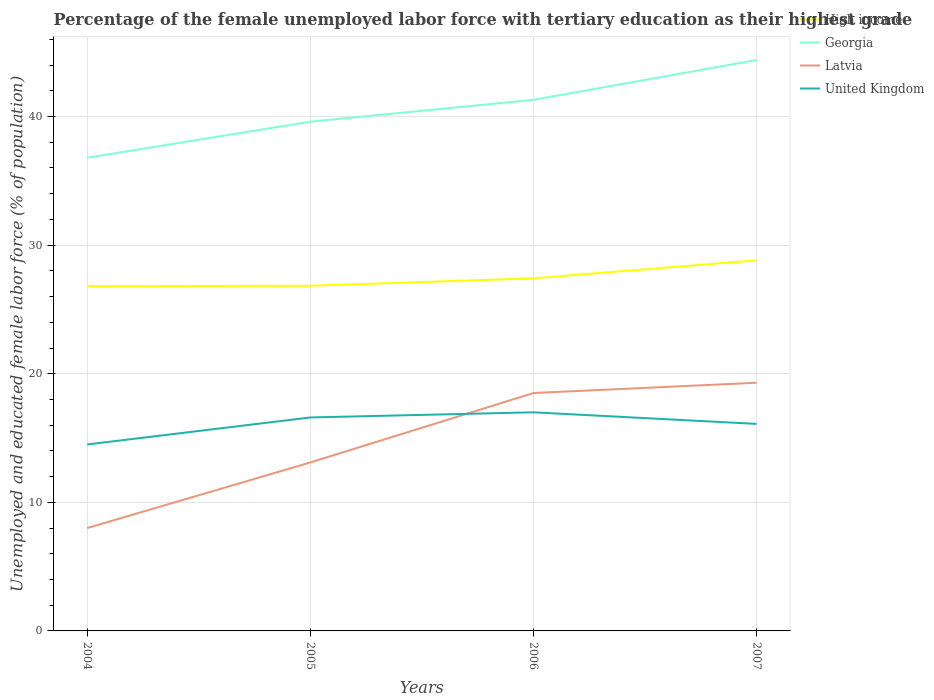Is the number of lines equal to the number of legend labels?
Provide a short and direct response. Yes. Across all years, what is the maximum percentage of the unemployed female labor force with tertiary education in High income?
Make the answer very short. 26.81. What is the difference between the highest and the second highest percentage of the unemployed female labor force with tertiary education in Georgia?
Make the answer very short. 7.6. How many lines are there?
Ensure brevity in your answer.  4. How many years are there in the graph?
Provide a succinct answer. 4. Are the values on the major ticks of Y-axis written in scientific E-notation?
Provide a succinct answer. No. Where does the legend appear in the graph?
Your answer should be compact. Top right. What is the title of the graph?
Offer a terse response. Percentage of the female unemployed labor force with tertiary education as their highest grade. Does "Virgin Islands" appear as one of the legend labels in the graph?
Make the answer very short. No. What is the label or title of the Y-axis?
Your answer should be very brief. Unemployed and educated female labor force (% of population). What is the Unemployed and educated female labor force (% of population) of High income in 2004?
Make the answer very short. 26.81. What is the Unemployed and educated female labor force (% of population) of Georgia in 2004?
Provide a succinct answer. 36.8. What is the Unemployed and educated female labor force (% of population) of United Kingdom in 2004?
Provide a succinct answer. 14.5. What is the Unemployed and educated female labor force (% of population) in High income in 2005?
Your answer should be very brief. 26.84. What is the Unemployed and educated female labor force (% of population) of Georgia in 2005?
Provide a short and direct response. 39.6. What is the Unemployed and educated female labor force (% of population) of Latvia in 2005?
Keep it short and to the point. 13.1. What is the Unemployed and educated female labor force (% of population) in United Kingdom in 2005?
Your answer should be compact. 16.6. What is the Unemployed and educated female labor force (% of population) in High income in 2006?
Offer a terse response. 27.42. What is the Unemployed and educated female labor force (% of population) of Georgia in 2006?
Keep it short and to the point. 41.3. What is the Unemployed and educated female labor force (% of population) of Latvia in 2006?
Ensure brevity in your answer.  18.5. What is the Unemployed and educated female labor force (% of population) in United Kingdom in 2006?
Ensure brevity in your answer.  17. What is the Unemployed and educated female labor force (% of population) in High income in 2007?
Provide a succinct answer. 28.82. What is the Unemployed and educated female labor force (% of population) of Georgia in 2007?
Provide a short and direct response. 44.4. What is the Unemployed and educated female labor force (% of population) in Latvia in 2007?
Your answer should be compact. 19.3. What is the Unemployed and educated female labor force (% of population) in United Kingdom in 2007?
Offer a very short reply. 16.1. Across all years, what is the maximum Unemployed and educated female labor force (% of population) in High income?
Provide a succinct answer. 28.82. Across all years, what is the maximum Unemployed and educated female labor force (% of population) in Georgia?
Make the answer very short. 44.4. Across all years, what is the maximum Unemployed and educated female labor force (% of population) of Latvia?
Ensure brevity in your answer.  19.3. Across all years, what is the maximum Unemployed and educated female labor force (% of population) of United Kingdom?
Ensure brevity in your answer.  17. Across all years, what is the minimum Unemployed and educated female labor force (% of population) in High income?
Offer a terse response. 26.81. Across all years, what is the minimum Unemployed and educated female labor force (% of population) of Georgia?
Provide a short and direct response. 36.8. Across all years, what is the minimum Unemployed and educated female labor force (% of population) in Latvia?
Keep it short and to the point. 8. What is the total Unemployed and educated female labor force (% of population) of High income in the graph?
Your response must be concise. 109.89. What is the total Unemployed and educated female labor force (% of population) in Georgia in the graph?
Ensure brevity in your answer.  162.1. What is the total Unemployed and educated female labor force (% of population) in Latvia in the graph?
Provide a succinct answer. 58.9. What is the total Unemployed and educated female labor force (% of population) in United Kingdom in the graph?
Ensure brevity in your answer.  64.2. What is the difference between the Unemployed and educated female labor force (% of population) in High income in 2004 and that in 2005?
Offer a very short reply. -0.03. What is the difference between the Unemployed and educated female labor force (% of population) of Georgia in 2004 and that in 2005?
Provide a succinct answer. -2.8. What is the difference between the Unemployed and educated female labor force (% of population) in Latvia in 2004 and that in 2005?
Your answer should be compact. -5.1. What is the difference between the Unemployed and educated female labor force (% of population) of United Kingdom in 2004 and that in 2005?
Make the answer very short. -2.1. What is the difference between the Unemployed and educated female labor force (% of population) of High income in 2004 and that in 2006?
Offer a terse response. -0.61. What is the difference between the Unemployed and educated female labor force (% of population) in High income in 2004 and that in 2007?
Ensure brevity in your answer.  -2.01. What is the difference between the Unemployed and educated female labor force (% of population) of High income in 2005 and that in 2006?
Make the answer very short. -0.58. What is the difference between the Unemployed and educated female labor force (% of population) of Georgia in 2005 and that in 2006?
Your response must be concise. -1.7. What is the difference between the Unemployed and educated female labor force (% of population) in Latvia in 2005 and that in 2006?
Your response must be concise. -5.4. What is the difference between the Unemployed and educated female labor force (% of population) in High income in 2005 and that in 2007?
Offer a terse response. -1.98. What is the difference between the Unemployed and educated female labor force (% of population) of Georgia in 2005 and that in 2007?
Your answer should be very brief. -4.8. What is the difference between the Unemployed and educated female labor force (% of population) in Latvia in 2005 and that in 2007?
Provide a short and direct response. -6.2. What is the difference between the Unemployed and educated female labor force (% of population) of United Kingdom in 2005 and that in 2007?
Provide a short and direct response. 0.5. What is the difference between the Unemployed and educated female labor force (% of population) of High income in 2006 and that in 2007?
Offer a terse response. -1.4. What is the difference between the Unemployed and educated female labor force (% of population) of Georgia in 2006 and that in 2007?
Offer a terse response. -3.1. What is the difference between the Unemployed and educated female labor force (% of population) of Latvia in 2006 and that in 2007?
Make the answer very short. -0.8. What is the difference between the Unemployed and educated female labor force (% of population) in United Kingdom in 2006 and that in 2007?
Provide a succinct answer. 0.9. What is the difference between the Unemployed and educated female labor force (% of population) in High income in 2004 and the Unemployed and educated female labor force (% of population) in Georgia in 2005?
Provide a short and direct response. -12.79. What is the difference between the Unemployed and educated female labor force (% of population) in High income in 2004 and the Unemployed and educated female labor force (% of population) in Latvia in 2005?
Ensure brevity in your answer.  13.71. What is the difference between the Unemployed and educated female labor force (% of population) in High income in 2004 and the Unemployed and educated female labor force (% of population) in United Kingdom in 2005?
Your response must be concise. 10.21. What is the difference between the Unemployed and educated female labor force (% of population) of Georgia in 2004 and the Unemployed and educated female labor force (% of population) of Latvia in 2005?
Provide a succinct answer. 23.7. What is the difference between the Unemployed and educated female labor force (% of population) of Georgia in 2004 and the Unemployed and educated female labor force (% of population) of United Kingdom in 2005?
Ensure brevity in your answer.  20.2. What is the difference between the Unemployed and educated female labor force (% of population) of Latvia in 2004 and the Unemployed and educated female labor force (% of population) of United Kingdom in 2005?
Offer a terse response. -8.6. What is the difference between the Unemployed and educated female labor force (% of population) of High income in 2004 and the Unemployed and educated female labor force (% of population) of Georgia in 2006?
Your answer should be compact. -14.49. What is the difference between the Unemployed and educated female labor force (% of population) of High income in 2004 and the Unemployed and educated female labor force (% of population) of Latvia in 2006?
Offer a terse response. 8.31. What is the difference between the Unemployed and educated female labor force (% of population) in High income in 2004 and the Unemployed and educated female labor force (% of population) in United Kingdom in 2006?
Your answer should be very brief. 9.81. What is the difference between the Unemployed and educated female labor force (% of population) of Georgia in 2004 and the Unemployed and educated female labor force (% of population) of Latvia in 2006?
Provide a short and direct response. 18.3. What is the difference between the Unemployed and educated female labor force (% of population) in Georgia in 2004 and the Unemployed and educated female labor force (% of population) in United Kingdom in 2006?
Provide a short and direct response. 19.8. What is the difference between the Unemployed and educated female labor force (% of population) of Latvia in 2004 and the Unemployed and educated female labor force (% of population) of United Kingdom in 2006?
Provide a short and direct response. -9. What is the difference between the Unemployed and educated female labor force (% of population) of High income in 2004 and the Unemployed and educated female labor force (% of population) of Georgia in 2007?
Make the answer very short. -17.59. What is the difference between the Unemployed and educated female labor force (% of population) in High income in 2004 and the Unemployed and educated female labor force (% of population) in Latvia in 2007?
Your response must be concise. 7.51. What is the difference between the Unemployed and educated female labor force (% of population) in High income in 2004 and the Unemployed and educated female labor force (% of population) in United Kingdom in 2007?
Your answer should be very brief. 10.71. What is the difference between the Unemployed and educated female labor force (% of population) of Georgia in 2004 and the Unemployed and educated female labor force (% of population) of Latvia in 2007?
Your answer should be compact. 17.5. What is the difference between the Unemployed and educated female labor force (% of population) of Georgia in 2004 and the Unemployed and educated female labor force (% of population) of United Kingdom in 2007?
Ensure brevity in your answer.  20.7. What is the difference between the Unemployed and educated female labor force (% of population) of Latvia in 2004 and the Unemployed and educated female labor force (% of population) of United Kingdom in 2007?
Your answer should be very brief. -8.1. What is the difference between the Unemployed and educated female labor force (% of population) of High income in 2005 and the Unemployed and educated female labor force (% of population) of Georgia in 2006?
Your answer should be compact. -14.46. What is the difference between the Unemployed and educated female labor force (% of population) of High income in 2005 and the Unemployed and educated female labor force (% of population) of Latvia in 2006?
Give a very brief answer. 8.34. What is the difference between the Unemployed and educated female labor force (% of population) of High income in 2005 and the Unemployed and educated female labor force (% of population) of United Kingdom in 2006?
Provide a short and direct response. 9.84. What is the difference between the Unemployed and educated female labor force (% of population) of Georgia in 2005 and the Unemployed and educated female labor force (% of population) of Latvia in 2006?
Ensure brevity in your answer.  21.1. What is the difference between the Unemployed and educated female labor force (% of population) of Georgia in 2005 and the Unemployed and educated female labor force (% of population) of United Kingdom in 2006?
Keep it short and to the point. 22.6. What is the difference between the Unemployed and educated female labor force (% of population) of High income in 2005 and the Unemployed and educated female labor force (% of population) of Georgia in 2007?
Ensure brevity in your answer.  -17.56. What is the difference between the Unemployed and educated female labor force (% of population) in High income in 2005 and the Unemployed and educated female labor force (% of population) in Latvia in 2007?
Your response must be concise. 7.54. What is the difference between the Unemployed and educated female labor force (% of population) of High income in 2005 and the Unemployed and educated female labor force (% of population) of United Kingdom in 2007?
Offer a very short reply. 10.74. What is the difference between the Unemployed and educated female labor force (% of population) of Georgia in 2005 and the Unemployed and educated female labor force (% of population) of Latvia in 2007?
Your answer should be compact. 20.3. What is the difference between the Unemployed and educated female labor force (% of population) of Georgia in 2005 and the Unemployed and educated female labor force (% of population) of United Kingdom in 2007?
Make the answer very short. 23.5. What is the difference between the Unemployed and educated female labor force (% of population) of High income in 2006 and the Unemployed and educated female labor force (% of population) of Georgia in 2007?
Ensure brevity in your answer.  -16.98. What is the difference between the Unemployed and educated female labor force (% of population) of High income in 2006 and the Unemployed and educated female labor force (% of population) of Latvia in 2007?
Give a very brief answer. 8.12. What is the difference between the Unemployed and educated female labor force (% of population) of High income in 2006 and the Unemployed and educated female labor force (% of population) of United Kingdom in 2007?
Make the answer very short. 11.32. What is the difference between the Unemployed and educated female labor force (% of population) of Georgia in 2006 and the Unemployed and educated female labor force (% of population) of United Kingdom in 2007?
Keep it short and to the point. 25.2. What is the difference between the Unemployed and educated female labor force (% of population) of Latvia in 2006 and the Unemployed and educated female labor force (% of population) of United Kingdom in 2007?
Your response must be concise. 2.4. What is the average Unemployed and educated female labor force (% of population) of High income per year?
Provide a succinct answer. 27.47. What is the average Unemployed and educated female labor force (% of population) in Georgia per year?
Provide a succinct answer. 40.52. What is the average Unemployed and educated female labor force (% of population) in Latvia per year?
Your response must be concise. 14.72. What is the average Unemployed and educated female labor force (% of population) in United Kingdom per year?
Offer a terse response. 16.05. In the year 2004, what is the difference between the Unemployed and educated female labor force (% of population) in High income and Unemployed and educated female labor force (% of population) in Georgia?
Give a very brief answer. -9.99. In the year 2004, what is the difference between the Unemployed and educated female labor force (% of population) in High income and Unemployed and educated female labor force (% of population) in Latvia?
Your answer should be very brief. 18.81. In the year 2004, what is the difference between the Unemployed and educated female labor force (% of population) of High income and Unemployed and educated female labor force (% of population) of United Kingdom?
Give a very brief answer. 12.31. In the year 2004, what is the difference between the Unemployed and educated female labor force (% of population) in Georgia and Unemployed and educated female labor force (% of population) in Latvia?
Ensure brevity in your answer.  28.8. In the year 2004, what is the difference between the Unemployed and educated female labor force (% of population) in Georgia and Unemployed and educated female labor force (% of population) in United Kingdom?
Provide a succinct answer. 22.3. In the year 2005, what is the difference between the Unemployed and educated female labor force (% of population) in High income and Unemployed and educated female labor force (% of population) in Georgia?
Your answer should be compact. -12.76. In the year 2005, what is the difference between the Unemployed and educated female labor force (% of population) of High income and Unemployed and educated female labor force (% of population) of Latvia?
Make the answer very short. 13.74. In the year 2005, what is the difference between the Unemployed and educated female labor force (% of population) of High income and Unemployed and educated female labor force (% of population) of United Kingdom?
Offer a terse response. 10.24. In the year 2005, what is the difference between the Unemployed and educated female labor force (% of population) in Georgia and Unemployed and educated female labor force (% of population) in United Kingdom?
Make the answer very short. 23. In the year 2005, what is the difference between the Unemployed and educated female labor force (% of population) of Latvia and Unemployed and educated female labor force (% of population) of United Kingdom?
Provide a short and direct response. -3.5. In the year 2006, what is the difference between the Unemployed and educated female labor force (% of population) in High income and Unemployed and educated female labor force (% of population) in Georgia?
Offer a terse response. -13.88. In the year 2006, what is the difference between the Unemployed and educated female labor force (% of population) of High income and Unemployed and educated female labor force (% of population) of Latvia?
Offer a very short reply. 8.92. In the year 2006, what is the difference between the Unemployed and educated female labor force (% of population) in High income and Unemployed and educated female labor force (% of population) in United Kingdom?
Provide a succinct answer. 10.42. In the year 2006, what is the difference between the Unemployed and educated female labor force (% of population) of Georgia and Unemployed and educated female labor force (% of population) of Latvia?
Keep it short and to the point. 22.8. In the year 2006, what is the difference between the Unemployed and educated female labor force (% of population) of Georgia and Unemployed and educated female labor force (% of population) of United Kingdom?
Provide a succinct answer. 24.3. In the year 2006, what is the difference between the Unemployed and educated female labor force (% of population) in Latvia and Unemployed and educated female labor force (% of population) in United Kingdom?
Your response must be concise. 1.5. In the year 2007, what is the difference between the Unemployed and educated female labor force (% of population) in High income and Unemployed and educated female labor force (% of population) in Georgia?
Ensure brevity in your answer.  -15.58. In the year 2007, what is the difference between the Unemployed and educated female labor force (% of population) in High income and Unemployed and educated female labor force (% of population) in Latvia?
Give a very brief answer. 9.52. In the year 2007, what is the difference between the Unemployed and educated female labor force (% of population) of High income and Unemployed and educated female labor force (% of population) of United Kingdom?
Offer a terse response. 12.72. In the year 2007, what is the difference between the Unemployed and educated female labor force (% of population) in Georgia and Unemployed and educated female labor force (% of population) in Latvia?
Ensure brevity in your answer.  25.1. In the year 2007, what is the difference between the Unemployed and educated female labor force (% of population) in Georgia and Unemployed and educated female labor force (% of population) in United Kingdom?
Your answer should be very brief. 28.3. What is the ratio of the Unemployed and educated female labor force (% of population) in Georgia in 2004 to that in 2005?
Provide a short and direct response. 0.93. What is the ratio of the Unemployed and educated female labor force (% of population) of Latvia in 2004 to that in 2005?
Your answer should be compact. 0.61. What is the ratio of the Unemployed and educated female labor force (% of population) of United Kingdom in 2004 to that in 2005?
Ensure brevity in your answer.  0.87. What is the ratio of the Unemployed and educated female labor force (% of population) of High income in 2004 to that in 2006?
Give a very brief answer. 0.98. What is the ratio of the Unemployed and educated female labor force (% of population) of Georgia in 2004 to that in 2006?
Keep it short and to the point. 0.89. What is the ratio of the Unemployed and educated female labor force (% of population) in Latvia in 2004 to that in 2006?
Give a very brief answer. 0.43. What is the ratio of the Unemployed and educated female labor force (% of population) in United Kingdom in 2004 to that in 2006?
Your answer should be very brief. 0.85. What is the ratio of the Unemployed and educated female labor force (% of population) in High income in 2004 to that in 2007?
Keep it short and to the point. 0.93. What is the ratio of the Unemployed and educated female labor force (% of population) in Georgia in 2004 to that in 2007?
Provide a short and direct response. 0.83. What is the ratio of the Unemployed and educated female labor force (% of population) of Latvia in 2004 to that in 2007?
Keep it short and to the point. 0.41. What is the ratio of the Unemployed and educated female labor force (% of population) of United Kingdom in 2004 to that in 2007?
Give a very brief answer. 0.9. What is the ratio of the Unemployed and educated female labor force (% of population) of High income in 2005 to that in 2006?
Offer a terse response. 0.98. What is the ratio of the Unemployed and educated female labor force (% of population) in Georgia in 2005 to that in 2006?
Keep it short and to the point. 0.96. What is the ratio of the Unemployed and educated female labor force (% of population) in Latvia in 2005 to that in 2006?
Provide a succinct answer. 0.71. What is the ratio of the Unemployed and educated female labor force (% of population) of United Kingdom in 2005 to that in 2006?
Provide a short and direct response. 0.98. What is the ratio of the Unemployed and educated female labor force (% of population) in High income in 2005 to that in 2007?
Provide a succinct answer. 0.93. What is the ratio of the Unemployed and educated female labor force (% of population) of Georgia in 2005 to that in 2007?
Ensure brevity in your answer.  0.89. What is the ratio of the Unemployed and educated female labor force (% of population) in Latvia in 2005 to that in 2007?
Ensure brevity in your answer.  0.68. What is the ratio of the Unemployed and educated female labor force (% of population) of United Kingdom in 2005 to that in 2007?
Provide a succinct answer. 1.03. What is the ratio of the Unemployed and educated female labor force (% of population) of High income in 2006 to that in 2007?
Make the answer very short. 0.95. What is the ratio of the Unemployed and educated female labor force (% of population) in Georgia in 2006 to that in 2007?
Keep it short and to the point. 0.93. What is the ratio of the Unemployed and educated female labor force (% of population) in Latvia in 2006 to that in 2007?
Offer a terse response. 0.96. What is the ratio of the Unemployed and educated female labor force (% of population) of United Kingdom in 2006 to that in 2007?
Make the answer very short. 1.06. What is the difference between the highest and the second highest Unemployed and educated female labor force (% of population) in High income?
Your answer should be very brief. 1.4. What is the difference between the highest and the second highest Unemployed and educated female labor force (% of population) of United Kingdom?
Offer a terse response. 0.4. What is the difference between the highest and the lowest Unemployed and educated female labor force (% of population) in High income?
Provide a short and direct response. 2.01. What is the difference between the highest and the lowest Unemployed and educated female labor force (% of population) of Georgia?
Provide a succinct answer. 7.6. What is the difference between the highest and the lowest Unemployed and educated female labor force (% of population) in United Kingdom?
Offer a terse response. 2.5. 